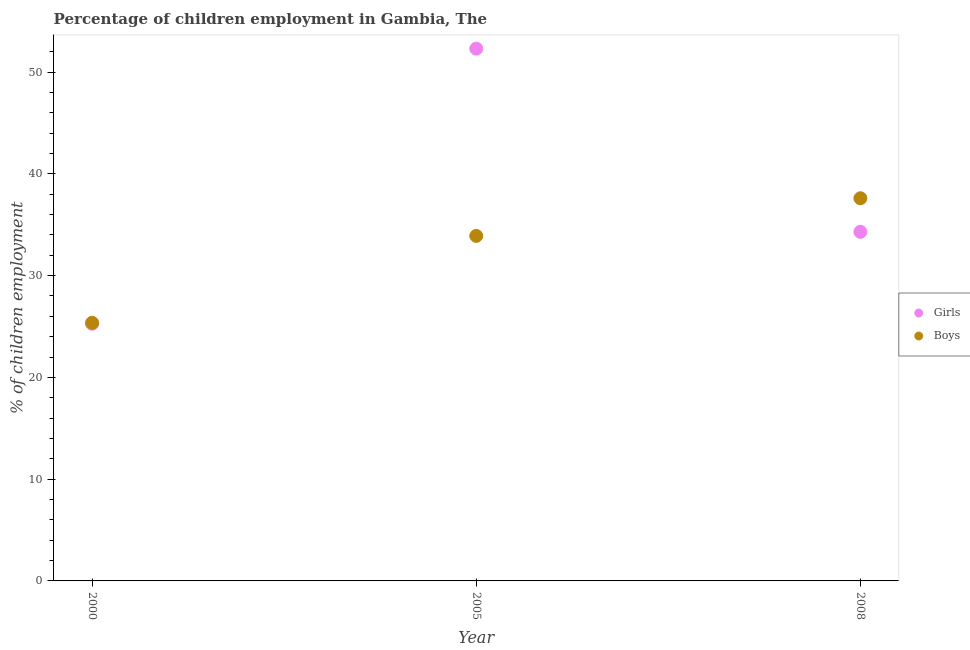What is the percentage of employed boys in 2000?
Offer a terse response. 25.36. Across all years, what is the maximum percentage of employed girls?
Offer a terse response. 52.3. Across all years, what is the minimum percentage of employed boys?
Provide a succinct answer. 25.36. In which year was the percentage of employed girls maximum?
Your answer should be compact. 2005. What is the total percentage of employed girls in the graph?
Provide a succinct answer. 111.87. What is the difference between the percentage of employed boys in 2000 and that in 2008?
Provide a short and direct response. -12.24. What is the difference between the percentage of employed boys in 2000 and the percentage of employed girls in 2008?
Your answer should be very brief. -8.94. What is the average percentage of employed girls per year?
Your answer should be very brief. 37.29. In the year 2008, what is the difference between the percentage of employed boys and percentage of employed girls?
Ensure brevity in your answer.  3.3. What is the ratio of the percentage of employed girls in 2000 to that in 2008?
Provide a succinct answer. 0.74. Is the percentage of employed girls in 2005 less than that in 2008?
Your response must be concise. No. Is the difference between the percentage of employed girls in 2000 and 2008 greater than the difference between the percentage of employed boys in 2000 and 2008?
Your response must be concise. Yes. What is the difference between the highest and the second highest percentage of employed boys?
Keep it short and to the point. 3.7. What is the difference between the highest and the lowest percentage of employed boys?
Your response must be concise. 12.24. Is the sum of the percentage of employed girls in 2000 and 2005 greater than the maximum percentage of employed boys across all years?
Your answer should be compact. Yes. Does the percentage of employed boys monotonically increase over the years?
Your answer should be compact. Yes. What is the difference between two consecutive major ticks on the Y-axis?
Provide a short and direct response. 10. Does the graph contain any zero values?
Keep it short and to the point. No. How many legend labels are there?
Offer a terse response. 2. How are the legend labels stacked?
Provide a short and direct response. Vertical. What is the title of the graph?
Your answer should be compact. Percentage of children employment in Gambia, The. Does "Grants" appear as one of the legend labels in the graph?
Make the answer very short. No. What is the label or title of the Y-axis?
Your answer should be compact. % of children employment. What is the % of children employment of Girls in 2000?
Provide a succinct answer. 25.27. What is the % of children employment of Boys in 2000?
Give a very brief answer. 25.36. What is the % of children employment of Girls in 2005?
Give a very brief answer. 52.3. What is the % of children employment of Boys in 2005?
Give a very brief answer. 33.9. What is the % of children employment of Girls in 2008?
Provide a succinct answer. 34.3. What is the % of children employment in Boys in 2008?
Offer a terse response. 37.6. Across all years, what is the maximum % of children employment of Girls?
Give a very brief answer. 52.3. Across all years, what is the maximum % of children employment of Boys?
Ensure brevity in your answer.  37.6. Across all years, what is the minimum % of children employment of Girls?
Your answer should be compact. 25.27. Across all years, what is the minimum % of children employment in Boys?
Your answer should be very brief. 25.36. What is the total % of children employment in Girls in the graph?
Your answer should be very brief. 111.87. What is the total % of children employment of Boys in the graph?
Provide a short and direct response. 96.86. What is the difference between the % of children employment of Girls in 2000 and that in 2005?
Keep it short and to the point. -27.03. What is the difference between the % of children employment in Boys in 2000 and that in 2005?
Keep it short and to the point. -8.54. What is the difference between the % of children employment in Girls in 2000 and that in 2008?
Your answer should be very brief. -9.03. What is the difference between the % of children employment of Boys in 2000 and that in 2008?
Ensure brevity in your answer.  -12.24. What is the difference between the % of children employment in Girls in 2000 and the % of children employment in Boys in 2005?
Provide a succinct answer. -8.63. What is the difference between the % of children employment of Girls in 2000 and the % of children employment of Boys in 2008?
Keep it short and to the point. -12.33. What is the average % of children employment in Girls per year?
Offer a terse response. 37.29. What is the average % of children employment in Boys per year?
Your response must be concise. 32.29. In the year 2000, what is the difference between the % of children employment of Girls and % of children employment of Boys?
Give a very brief answer. -0.09. In the year 2005, what is the difference between the % of children employment of Girls and % of children employment of Boys?
Offer a very short reply. 18.4. In the year 2008, what is the difference between the % of children employment in Girls and % of children employment in Boys?
Ensure brevity in your answer.  -3.3. What is the ratio of the % of children employment of Girls in 2000 to that in 2005?
Your response must be concise. 0.48. What is the ratio of the % of children employment in Boys in 2000 to that in 2005?
Give a very brief answer. 0.75. What is the ratio of the % of children employment of Girls in 2000 to that in 2008?
Keep it short and to the point. 0.74. What is the ratio of the % of children employment in Boys in 2000 to that in 2008?
Provide a short and direct response. 0.67. What is the ratio of the % of children employment in Girls in 2005 to that in 2008?
Make the answer very short. 1.52. What is the ratio of the % of children employment in Boys in 2005 to that in 2008?
Your response must be concise. 0.9. What is the difference between the highest and the second highest % of children employment of Boys?
Provide a short and direct response. 3.7. What is the difference between the highest and the lowest % of children employment in Girls?
Keep it short and to the point. 27.03. What is the difference between the highest and the lowest % of children employment of Boys?
Offer a very short reply. 12.24. 